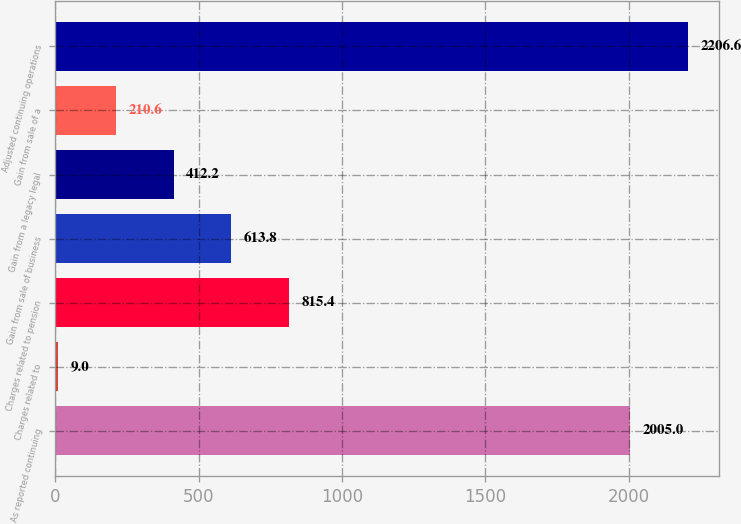Convert chart. <chart><loc_0><loc_0><loc_500><loc_500><bar_chart><fcel>As reported continuing<fcel>Charges related to<fcel>Charges related to pension<fcel>Gain from sale of business<fcel>Gain from a legacy legal<fcel>Gain from sale of a<fcel>Adjusted continuing operations<nl><fcel>2005<fcel>9<fcel>815.4<fcel>613.8<fcel>412.2<fcel>210.6<fcel>2206.6<nl></chart> 